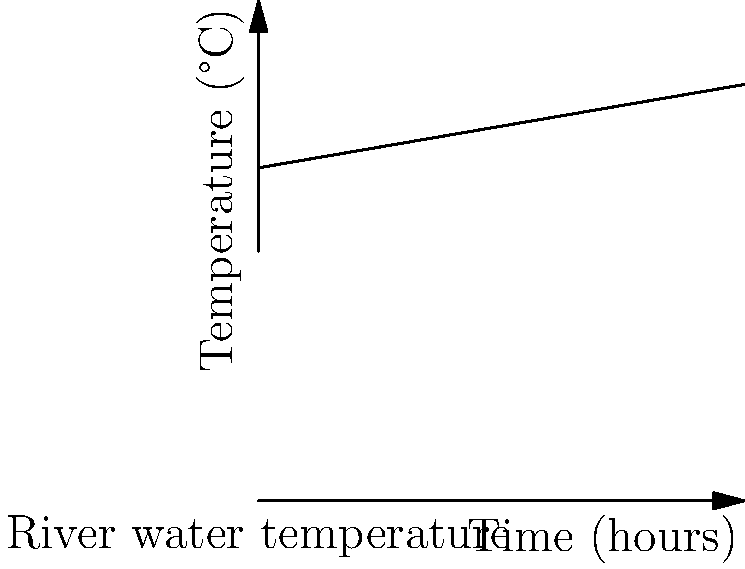A nuclear power plant discharges heated water into a nearby river. The graph shows the change in river water temperature over time after the plant begins operations. If the rate of temperature increase remains constant, what will be the water temperature after 24 hours? How does this potential temperature increase impact local aquatic ecosystems? To solve this problem, we need to follow these steps:

1. Identify the initial temperature:
   From the y-intercept, we can see that the initial temperature is 20°C.

2. Calculate the rate of temperature increase:
   The line rises from 20°C to 25°C over 10 hours.
   Rate = (25°C - 20°C) / 10 hours = 0.5°C/hour

3. Use the linear equation to predict the temperature at 24 hours:
   Temperature = Initial temperature + (Rate × Time)
   Temperature = 20°C + (0.5°C/hour × 24 hours) = 20°C + 12°C = 32°C

4. Consider the ecological impact:
   A 12°C increase in water temperature can have severe consequences for aquatic ecosystems:
   - Reduced dissolved oxygen levels
   - Altered metabolic rates of aquatic organisms
   - Potential loss of temperature-sensitive species
   - Increased algal blooms
   - Disruption of spawning and migration patterns

These effects could lead to a significant loss of biodiversity and ecosystem function in the river.
Answer: 32°C; severe ecological disruption due to reduced oxygen, altered metabolism, species loss, and ecosystem imbalance. 